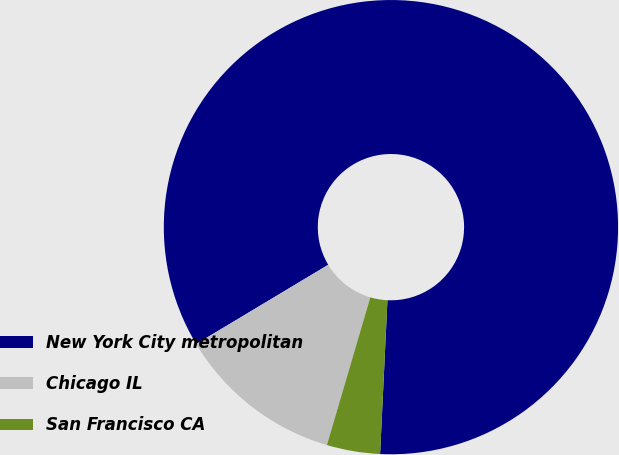Convert chart to OTSL. <chart><loc_0><loc_0><loc_500><loc_500><pie_chart><fcel>New York City metropolitan<fcel>Chicago IL<fcel>San Francisco CA<nl><fcel>84.36%<fcel>11.85%<fcel>3.79%<nl></chart> 